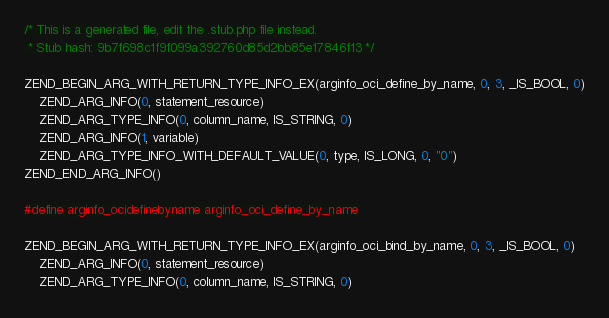<code> <loc_0><loc_0><loc_500><loc_500><_C_>/* This is a generated file, edit the .stub.php file instead.
 * Stub hash: 9b7f698c1f9f099a392760d85d2bb85e17846f13 */

ZEND_BEGIN_ARG_WITH_RETURN_TYPE_INFO_EX(arginfo_oci_define_by_name, 0, 3, _IS_BOOL, 0)
	ZEND_ARG_INFO(0, statement_resource)
	ZEND_ARG_TYPE_INFO(0, column_name, IS_STRING, 0)
	ZEND_ARG_INFO(1, variable)
	ZEND_ARG_TYPE_INFO_WITH_DEFAULT_VALUE(0, type, IS_LONG, 0, "0")
ZEND_END_ARG_INFO()

#define arginfo_ocidefinebyname arginfo_oci_define_by_name

ZEND_BEGIN_ARG_WITH_RETURN_TYPE_INFO_EX(arginfo_oci_bind_by_name, 0, 3, _IS_BOOL, 0)
	ZEND_ARG_INFO(0, statement_resource)
	ZEND_ARG_TYPE_INFO(0, column_name, IS_STRING, 0)</code> 